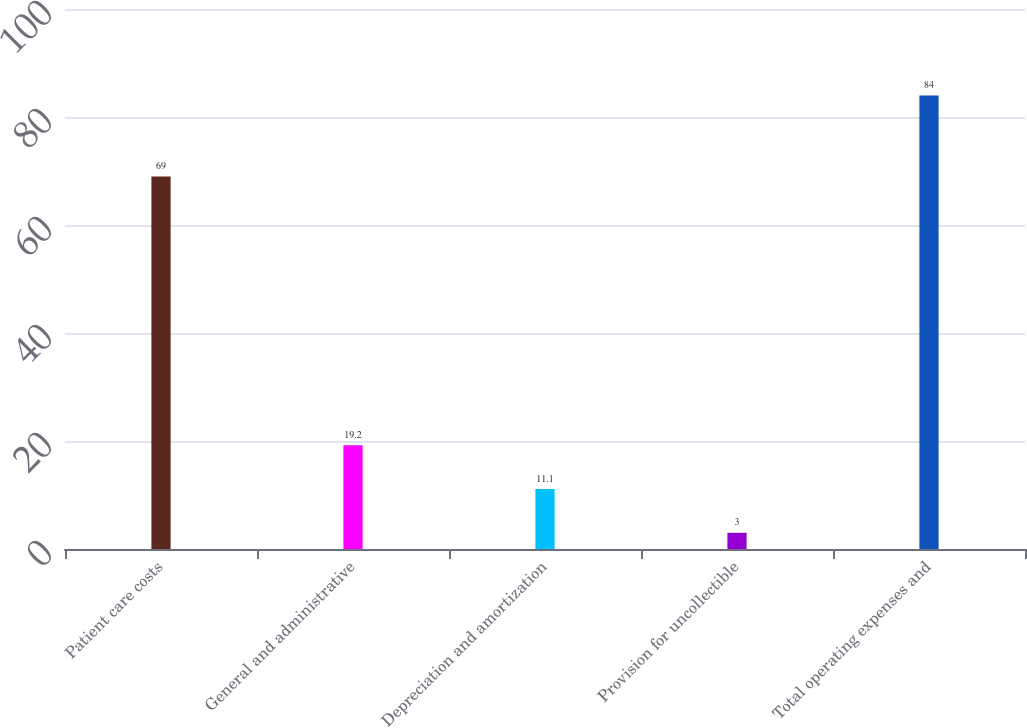<chart> <loc_0><loc_0><loc_500><loc_500><bar_chart><fcel>Patient care costs<fcel>General and administrative<fcel>Depreciation and amortization<fcel>Provision for uncollectible<fcel>Total operating expenses and<nl><fcel>69<fcel>19.2<fcel>11.1<fcel>3<fcel>84<nl></chart> 